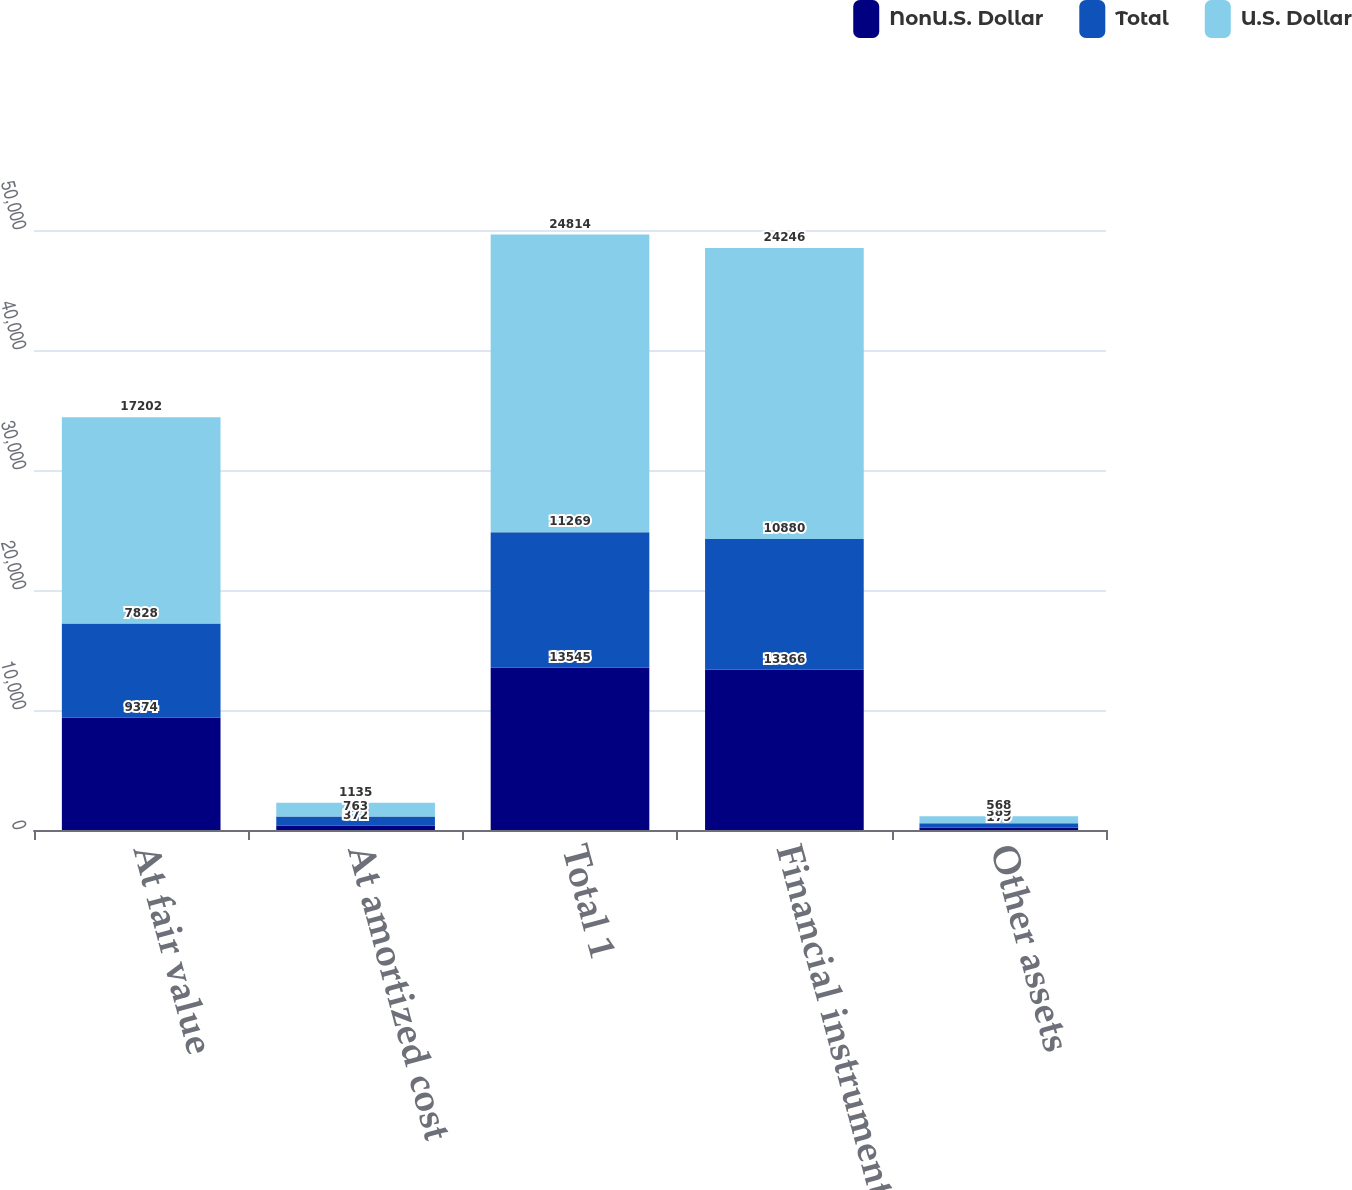Convert chart. <chart><loc_0><loc_0><loc_500><loc_500><stacked_bar_chart><ecel><fcel>At fair value<fcel>At amortized cost<fcel>Total 1<fcel>Financial instruments 2<fcel>Other assets<nl><fcel>NonU.S. Dollar<fcel>9374<fcel>372<fcel>13545<fcel>13366<fcel>179<nl><fcel>Total<fcel>7828<fcel>763<fcel>11269<fcel>10880<fcel>389<nl><fcel>U.S. Dollar<fcel>17202<fcel>1135<fcel>24814<fcel>24246<fcel>568<nl></chart> 